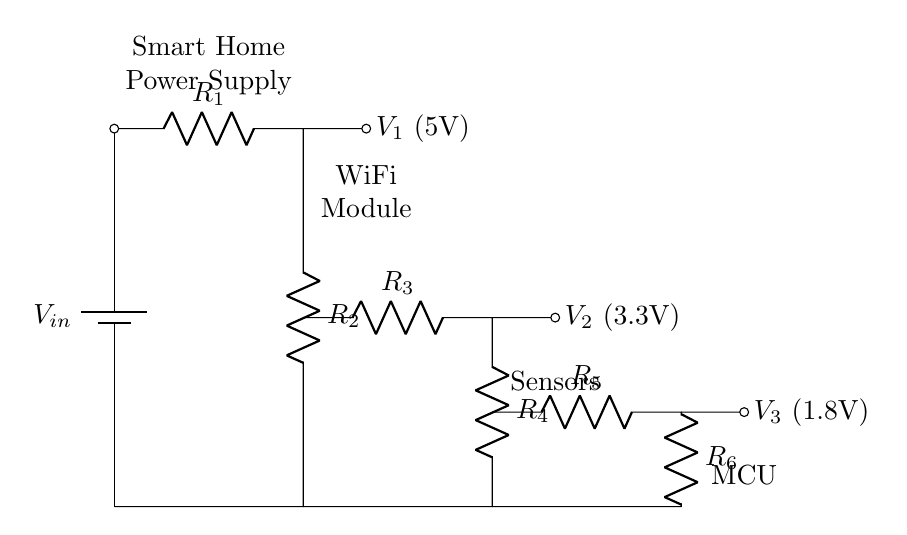What is the input voltage of this circuit? The input voltage is represented by the battery symbol at the top of the diagram, labeled as V_in.
Answer: V_in What resistor values are used in the first stage? The resistors in the first stage are labeled R_1 and R_2, but their specific values are not provided in the diagram.
Answer: R_1, R_2 What is the voltage output connected to the WiFi module? The output connected to the WiFi module is indicated by node V_1, which has a voltage of 5V.
Answer: 5V How many stages are there in this voltage divider? The diagram clearly shows three stages of voltage division, each marked by resistors that split the voltage across them.
Answer: 3 What is the voltage output for the sensors? The voltage output for the sensors, indicated by node V_2 in the circuit, is labeled as 3.3V.
Answer: 3.3V Which component receives the lowest output voltage? The component at the bottom of the circuit diagram, labeled as MCU, is connected to the voltage output V_3, which is the lowest output at 1.8V.
Answer: 1.8V Describe the connection type between the stages. The connection between the stages is a series connection of resistors, where the output of one stage serves as the input for the next stage.
Answer: Series 